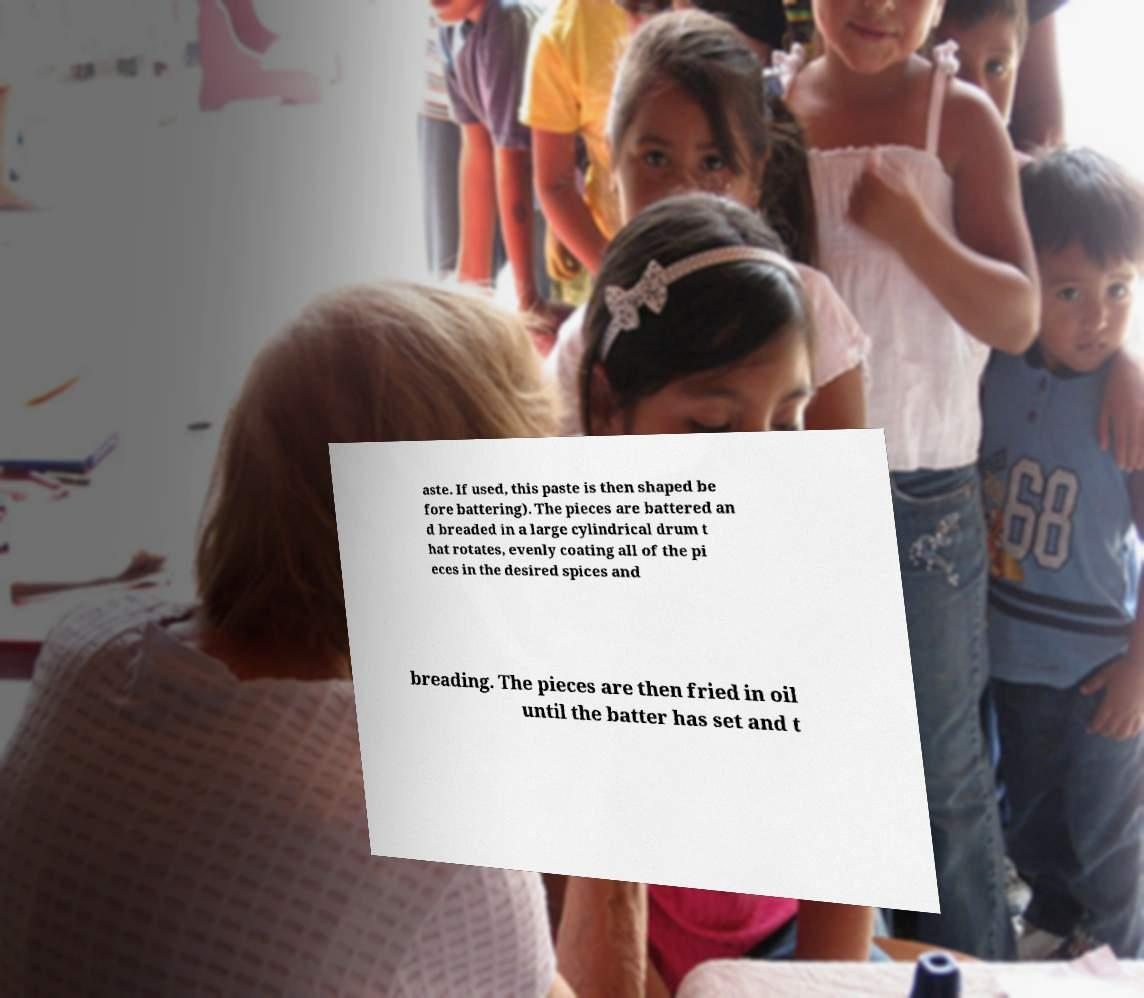Could you assist in decoding the text presented in this image and type it out clearly? aste. If used, this paste is then shaped be fore battering). The pieces are battered an d breaded in a large cylindrical drum t hat rotates, evenly coating all of the pi eces in the desired spices and breading. The pieces are then fried in oil until the batter has set and t 